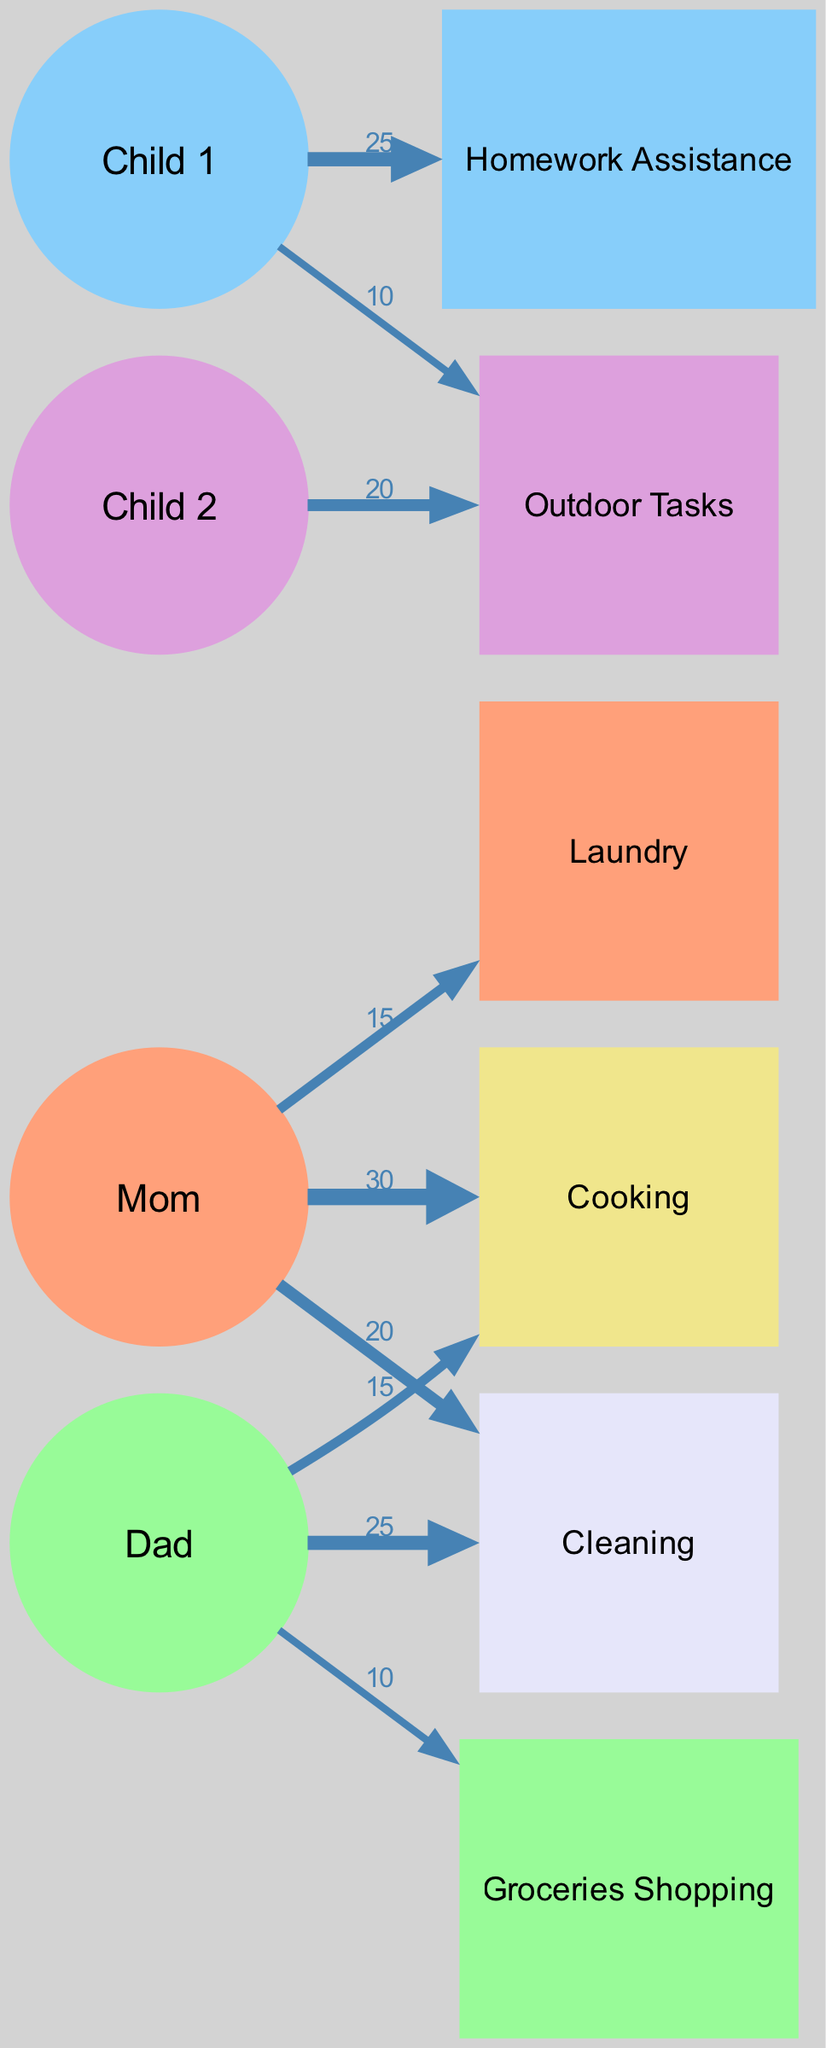What is the total time Mom spends on chores? To find the total time Mom spends, I need to add up the values associated with her tasks. According to the diagram, Mom spends 30 minutes on Cooking, 20 minutes on Cleaning, and 15 minutes on Laundry. Therefore, the total time is 30 + 20 + 15 = 65 minutes.
Answer: 65 minutes Which family member spends the most time on Cleaning? Looking at the diagram, Dad spends 25 minutes on Cleaning, while Mom spends 20 minutes. Since 25 is greater than 20, Dad is the family member who spends the most time on Cleaning.
Answer: Dad What task does Child 1 spend the most time on? By examining the diagram, Child 1 is connected to Homework Assistance with a value of 25 minutes and Outdoor Tasks with 10 minutes. Since 25 is greater than 10, Child 1 spends the most time on Homework Assistance.
Answer: Homework Assistance How much time is allocated to Grocery Shopping? The diagram indicates that Dad spends 10 minutes on Grocery Shopping. This is the only link for this task, so the time allocated is simply represented by this link.
Answer: 10 minutes What is the total time spent by all family members on Outdoor Tasks? To find the total time, I need to look at the contributions from both Child 2 and Child 1. Child 2 spends 20 minutes and Child 1 spends 10 minutes. Adding these together gives 20 + 10 = 30 minutes total for Outdoor Tasks.
Answer: 30 minutes Which chore has the least amount of time assigned to it? The diagram shows several tasks with their corresponding times. Checking each task, Laundry has the lowest value with Mom assigned 15 minutes. Therefore, Laundry is the chore with the least time assigned.
Answer: Laundry How much time does Dad spend on Cooking compared to Mom? From the diagram, Dad spends 15 minutes on Cooking while Mom spends 30 minutes. To compare, Mom's time is greater, specifically, she spends double the time that Dad does on Cooking.
Answer: 30 minutes for Mom, 15 minutes for Dad What percentage of total chores time is spent on Laundry by Mom? First, I need to calculate the total time spent on chores. Mom's total time is 65 minutes, Dad 60 minutes (25+10+15), and Child 1 25 and Child 2 20 minutes (total 45). Adding these up, the total time is 65 + 60 + 25 + 20 = 170 minutes. Now, to find the percentage allocated to Laundry, which is 15 minutes by Mom. Calculating (15/170)*100 gives approximately 8.82%.
Answer: Approximately 8.82% 